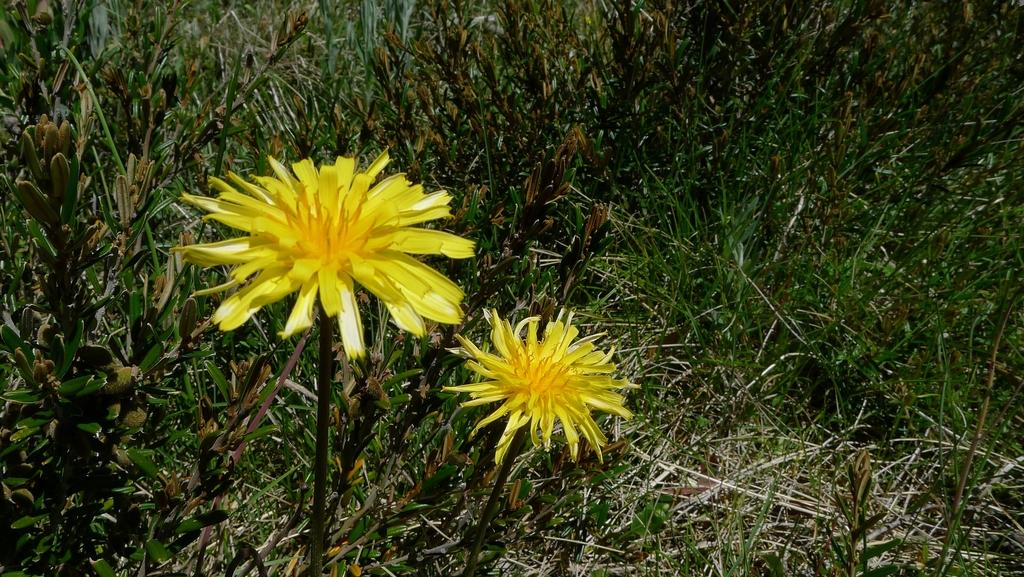How many flowers are present in the image? There are two flowers in the image. Where are the flowers located? The flowers are in a field. What type of crook can be seen using the flowers to begin a new project in the image? There is no crook or project present in the image; it simply features two flowers in a field. 